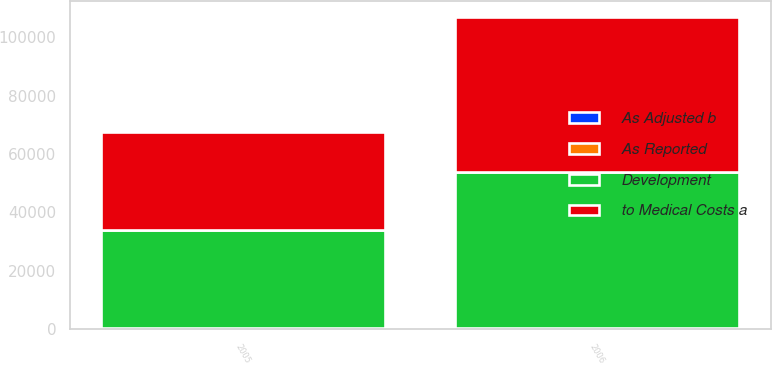<chart> <loc_0><loc_0><loc_500><loc_500><stacked_bar_chart><ecel><fcel>2005<fcel>2006<nl><fcel>As Reported<fcel>400<fcel>430<nl><fcel>As Adjusted b<fcel>30<fcel>10<nl><fcel>to Medical Costs a<fcel>33669<fcel>53308<nl><fcel>Development<fcel>33639<fcel>53318<nl></chart> 